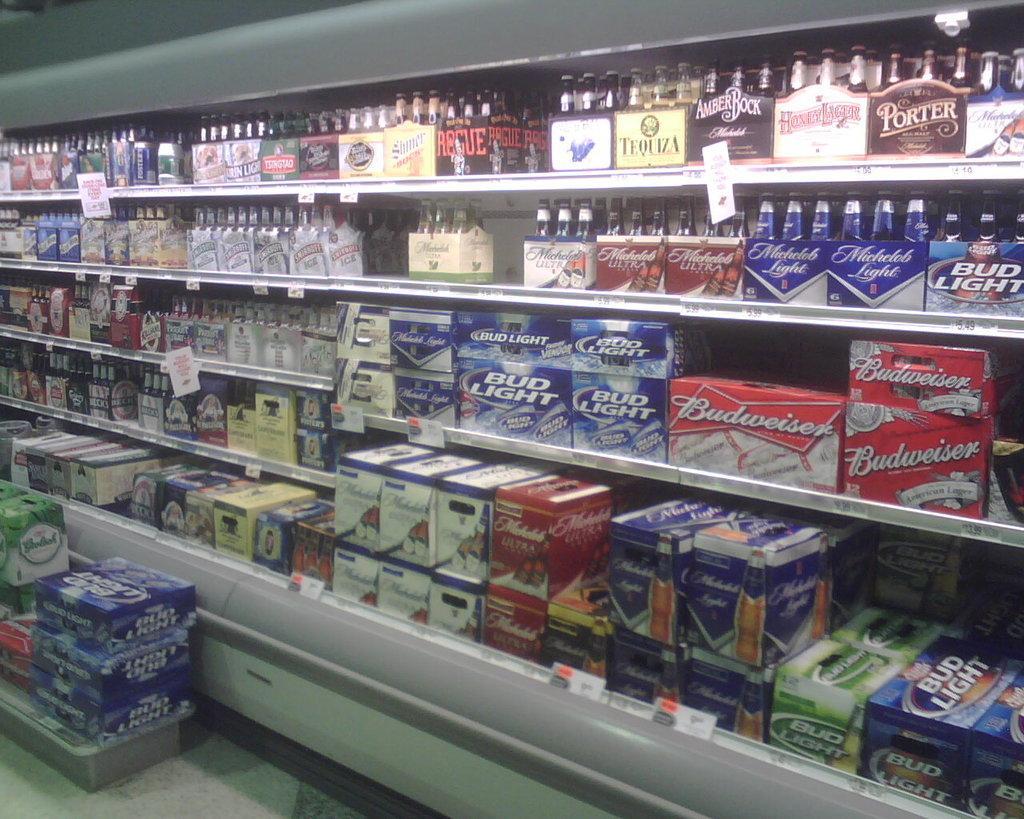In one or two sentences, can you explain what this image depicts? This image is taken in the store. In the center we can see beverages and cartons placed in the racks. At the bottom there are boxes. 